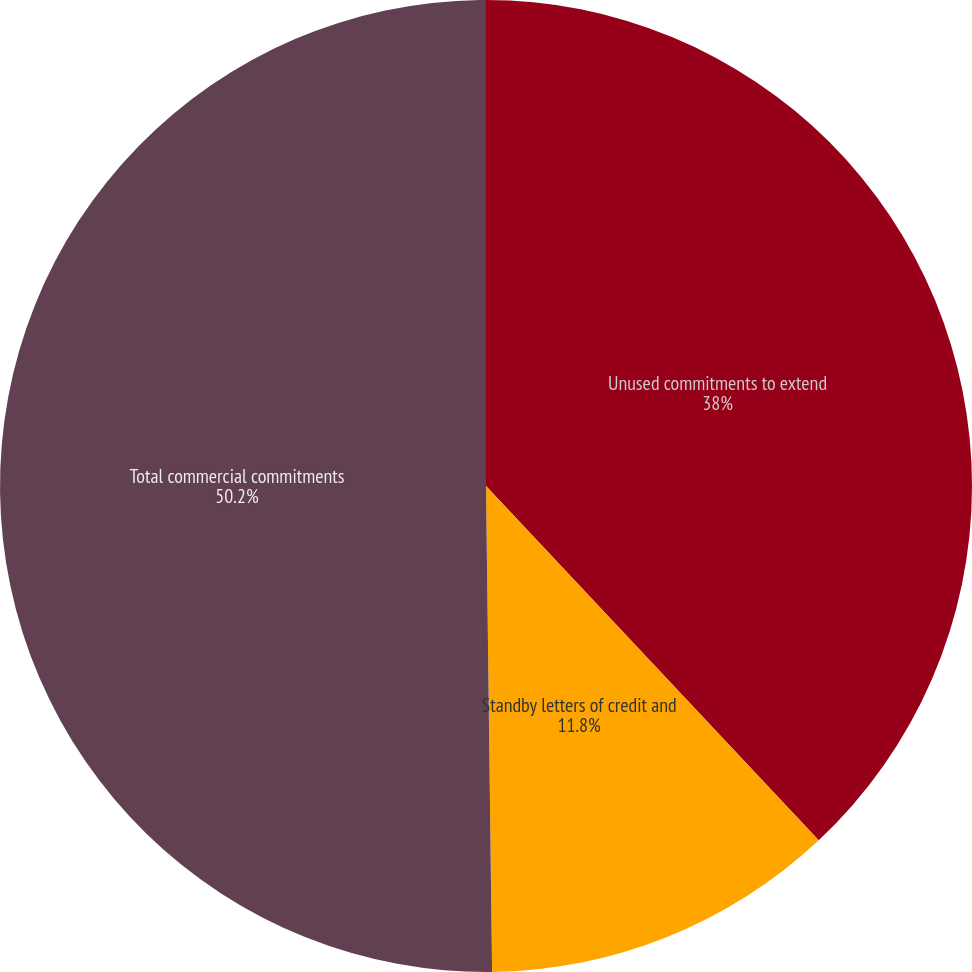<chart> <loc_0><loc_0><loc_500><loc_500><pie_chart><fcel>Unused commitments to extend<fcel>Standby letters of credit and<fcel>Total commercial commitments<nl><fcel>38.0%<fcel>11.8%<fcel>50.2%<nl></chart> 